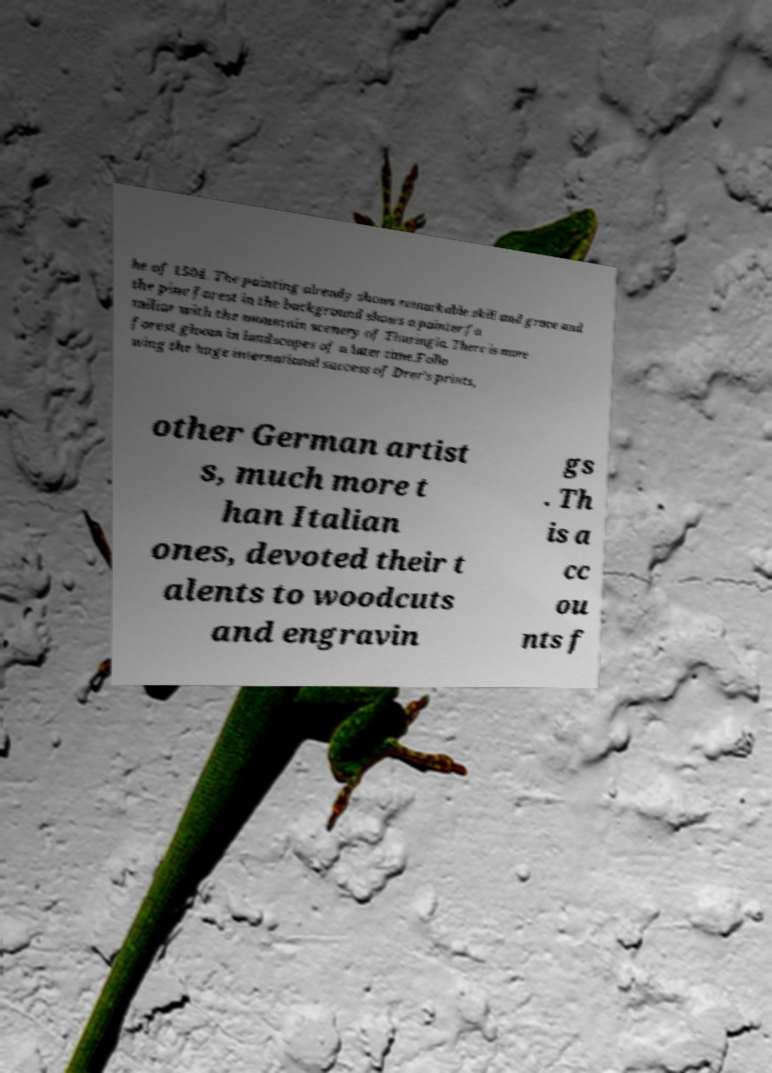Could you assist in decoding the text presented in this image and type it out clearly? he of 1504. The painting already shows remarkable skill and grace and the pine forest in the background shows a painter fa miliar with the mountain scenery of Thuringia. There is more forest gloom in landscapes of a later time.Follo wing the huge international success of Drer's prints, other German artist s, much more t han Italian ones, devoted their t alents to woodcuts and engravin gs . Th is a cc ou nts f 